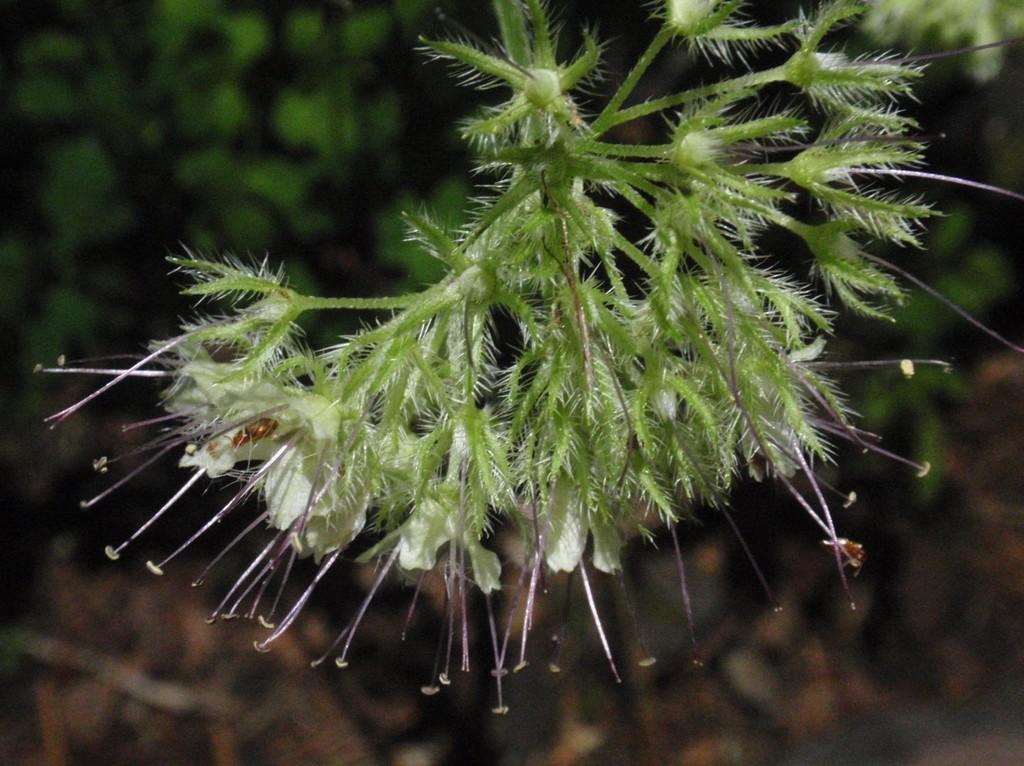In one or two sentences, can you explain what this image depicts? In this image there is a plant with white flowers, and there is blur background. 